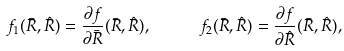<formula> <loc_0><loc_0><loc_500><loc_500>f _ { 1 } ( { \bar { R } } , { \hat { R } } ) = \frac { \partial f } { \partial { \bar { R } } } ( { \bar { R } } , { \hat { R } } ) , \quad \ \ f _ { 2 } ( { \bar { R } } , { \hat { R } } ) = \frac { \partial f } { \partial { \hat { R } } } ( { \bar { R } } , { \hat { R } } ) ,</formula> 